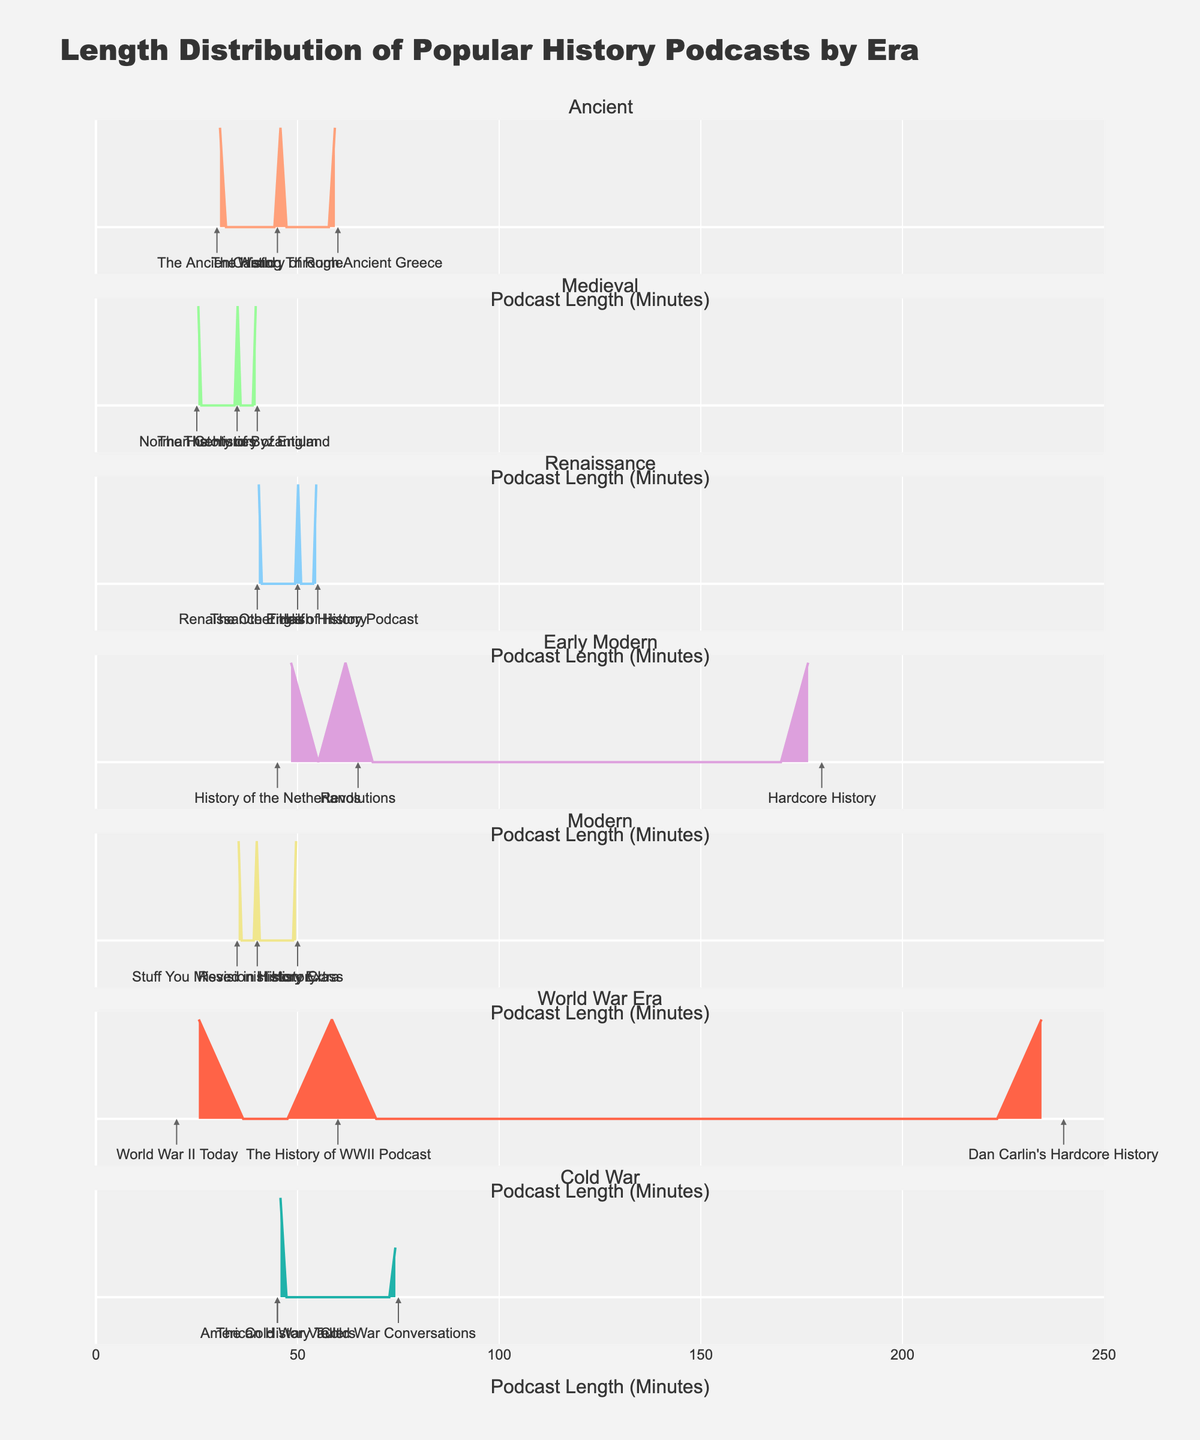What is the title of the plot? The title of the plot is usually found at the top of the figure and serves to describe what the figure is about. In this case, the title is **"Length Distribution of Popular History Podcasts by Era"**
Answer: Length Distribution of Popular History Podcasts by Era What is the color used for the "Ancient" era? The plot typically assigns specific colors to different eras for easy identification. For the "Ancient" era, the color used is light salmon. This can be observed from the color map and can also be corroborated by looking at the color used in the figure for the "Ancient" era.
Answer: Light salmon Which era has the longest average podcast length? To find the longest average podcast length, we need to compare the length distributions of podcasts across different eras. The "World War Era" has the most extended podcast lengths on average, as indicated by its density plot skewed towards higher values.
Answer: World War Era What is the shortest podcast in the "World War Era" era? The shortest podcast length in the "World War Era" is indicated by the leftmost point in its horizontal density plot. The podcast "World War II Today" has the shortest duration, which is 20 minutes.
Answer: 20 minutes Which era has the densest concentration of podcasts around the 40-minute mark? To determine this, look at the density peaks near the 40-minute mark. The "Medieval" era has the densest concentration of podcasts around 40 minutes, as shown by a high-density peak.
Answer: Medieval How many podcasts fall within the 30-60 minute range for the "Cold War" era? To answer this, count the annotations within the 30-60 minute range on the "Cold War" density plot. The podcasts in this range are "The Cold War Vault" and "American History Tellers," making a total of 2.
Answer: 2 Which podcast has the longest duration across all eras, and how long is it? Identify the longest single podcast by looking for the farthest point on the density plot. "Dan Carlin's Hardcore History" in the "World War Era" has the longest duration, which is 240 minutes.
Answer: Dan Carlin's Hardcore History, 240 minutes What is the range of podcast durations for the "Modern" era? The range can be found by identifying the minimum and maximum lengths in the "Modern" era's density plot. The minimum is 35 minutes, and the maximum is 50 minutes, so the range is 15 minutes.
Answer: 15 minutes What are the visual differences between the density plots of the "Ancient" and "Renaissance" eras? Compare the shapes and peaks of the two eras. The "Ancient" era has a bimodal distribution with peaks around 30 and 60 minutes, whereas the "Renaissance" era has a single peak around 50 minutes.
Answer: Ancient is bimodal (30 & 60 min), Renaissance is unimodal (50 min) Which era has the highest peak in terms of density, and what does it indicate about the podcast lengths in that era? Identify the tallest peak across all density plots. The "Cold War" era has the highest peak, indicating that a significant number of podcasts are concentrated around the 45-minute mark.
Answer: Cold War, 45-minute concentration 